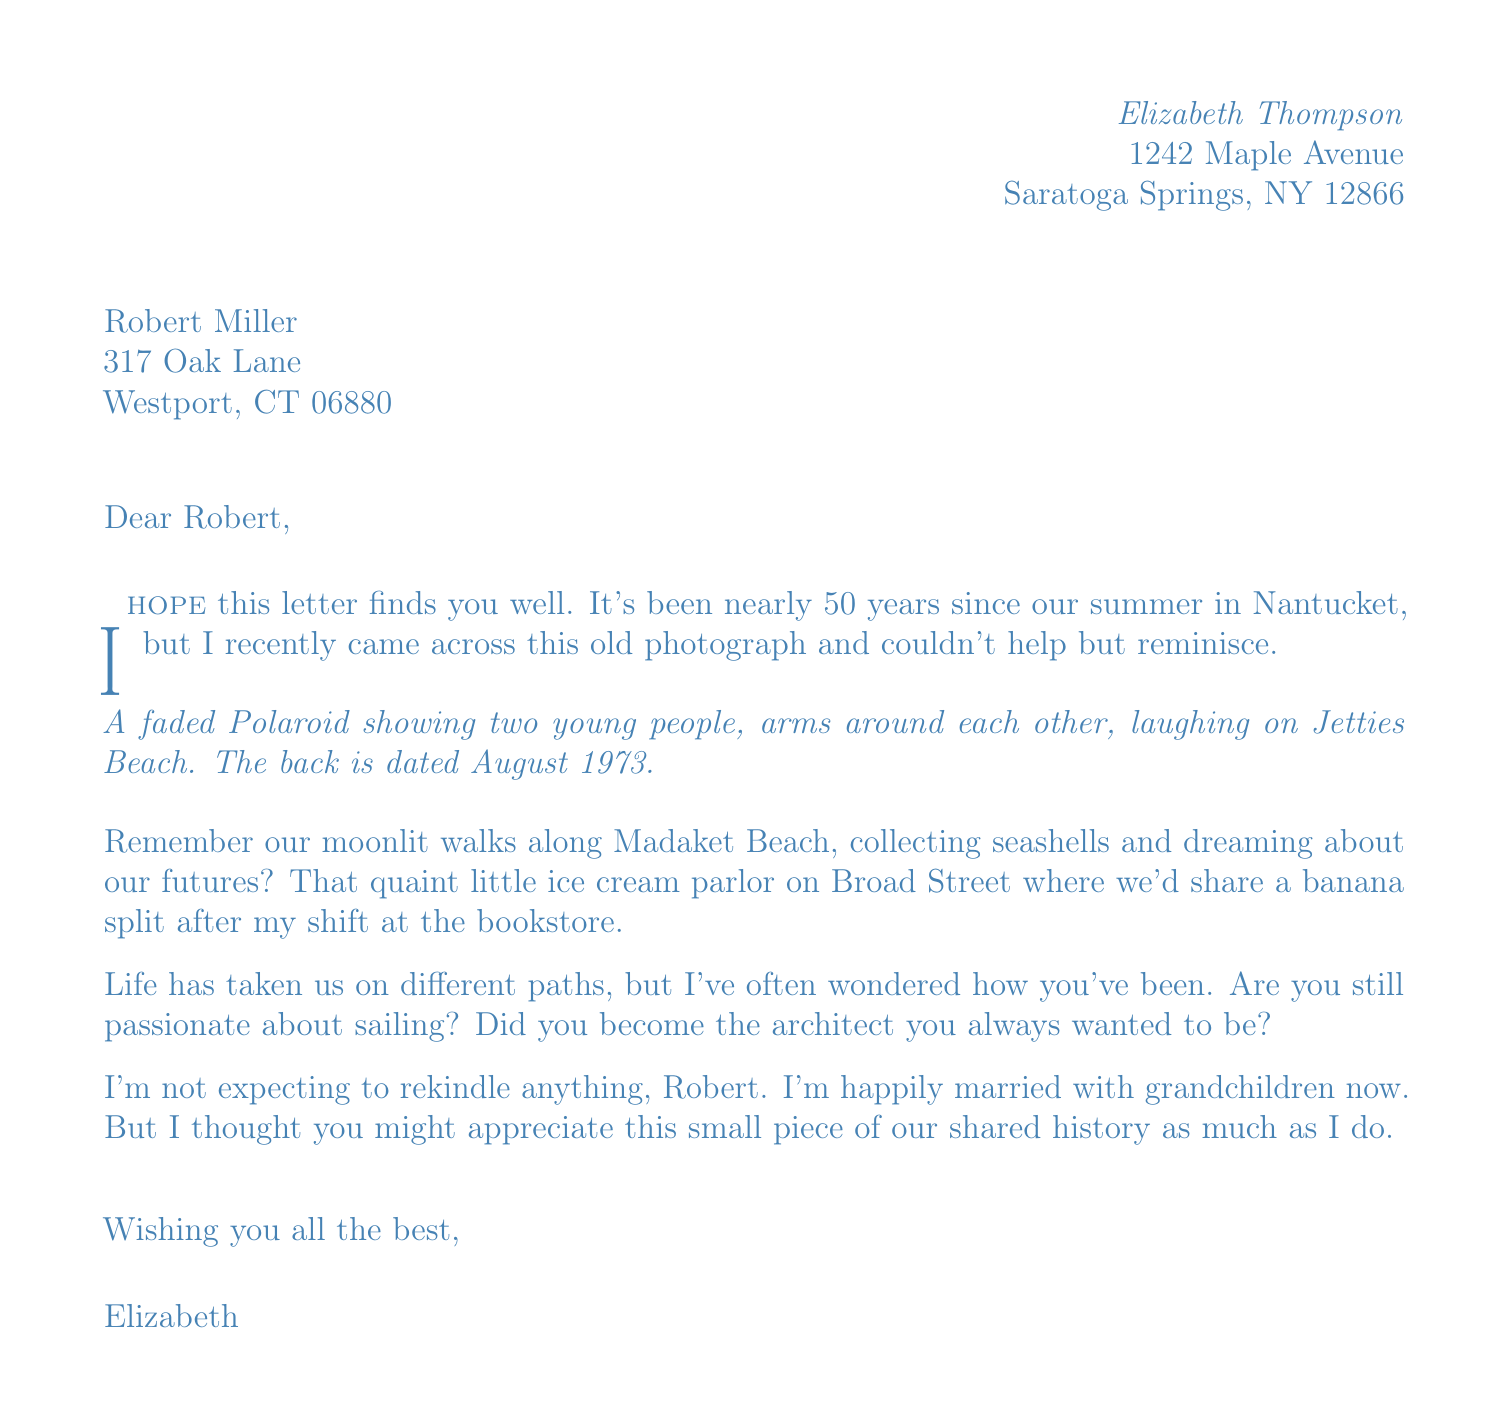What is the sender's name? The sender's name is stated at the beginning of the letter.
Answer: Elizabeth Thompson What is the recipient's address? The address of the recipient is specified in the document.
Answer: 317 Oak Lane, Westport, CT 06880 What year was the summer romance? The document mentions the year the romance took place.
Answer: 1973 What is described in the faded photograph? The letter gives a description of what is captured in the photograph.
Answer: Two young people, arms around each other, laughing on Jetties Beach How long did the romance last? The duration of the romance is specified in the context of the document.
Answer: 3 months (June to August) What does Elizabeth wish for Robert at the end of the letter? The closing wishes provide insight into the sender's sentiments.
Answer: All the best Why did Elizabeth write the letter? The reason for writing is expressed in the letter.
Answer: To share a piece of their shared history What was the couple's main activity at Madaket Beach? The letter recalls a specific activity the couple enjoyed together.
Answer: Collecting seashells What is Elizabeth's current family situation? The letter suggests Elizabeth's present family circumstances.
Answer: Happily married with grandchildren 